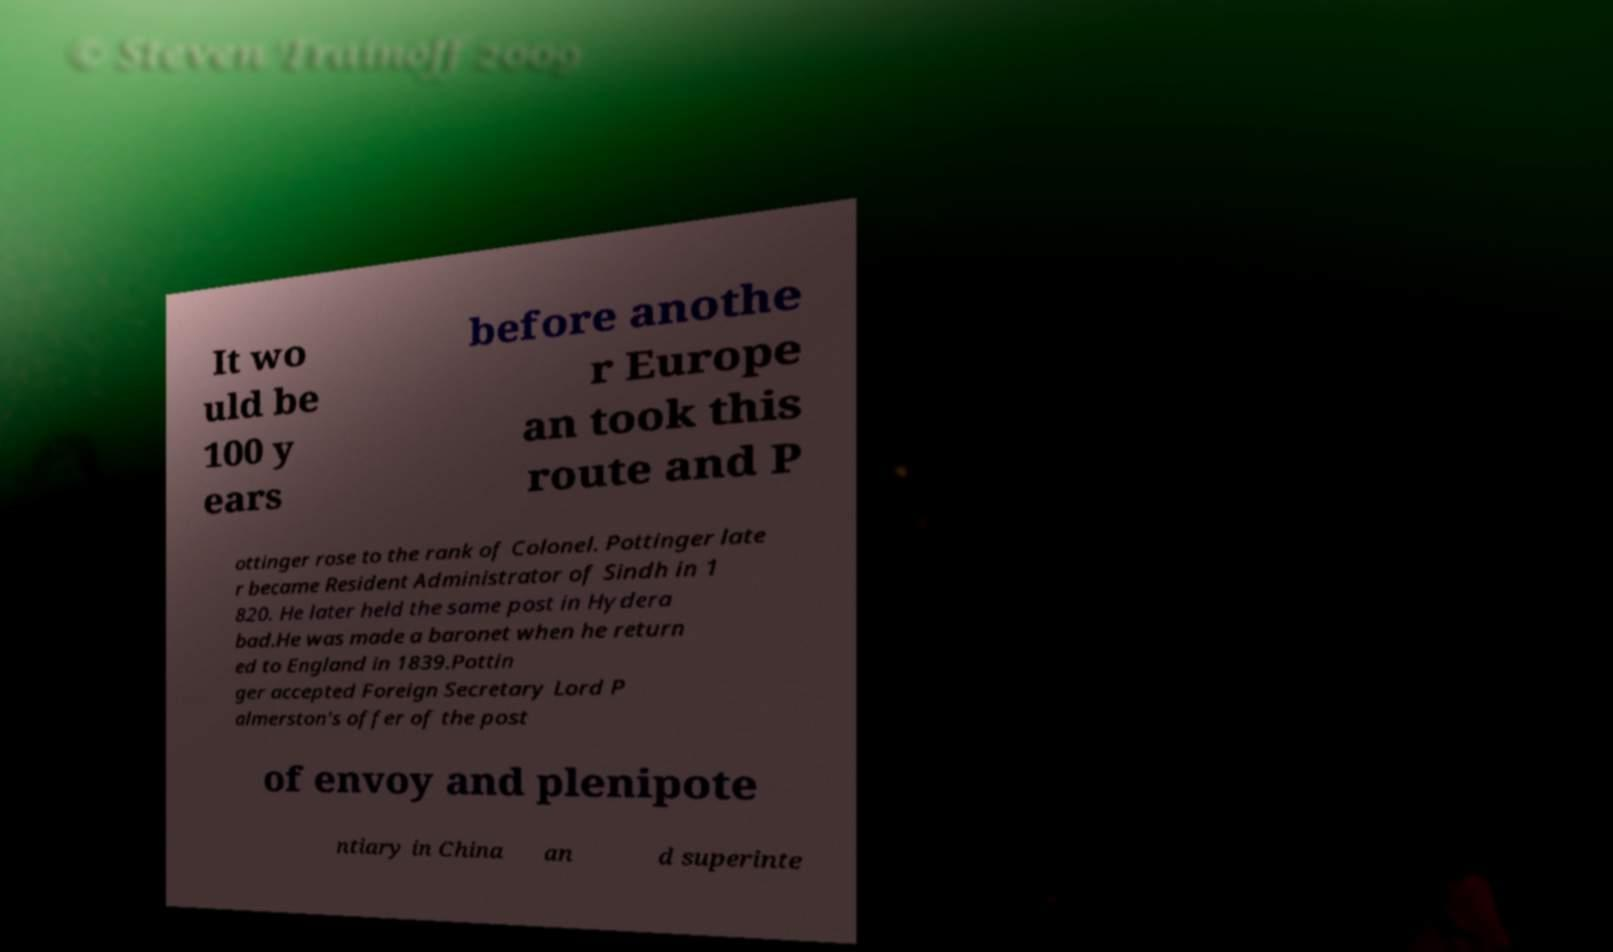Please identify and transcribe the text found in this image. It wo uld be 100 y ears before anothe r Europe an took this route and P ottinger rose to the rank of Colonel. Pottinger late r became Resident Administrator of Sindh in 1 820. He later held the same post in Hydera bad.He was made a baronet when he return ed to England in 1839.Pottin ger accepted Foreign Secretary Lord P almerston's offer of the post of envoy and plenipote ntiary in China an d superinte 